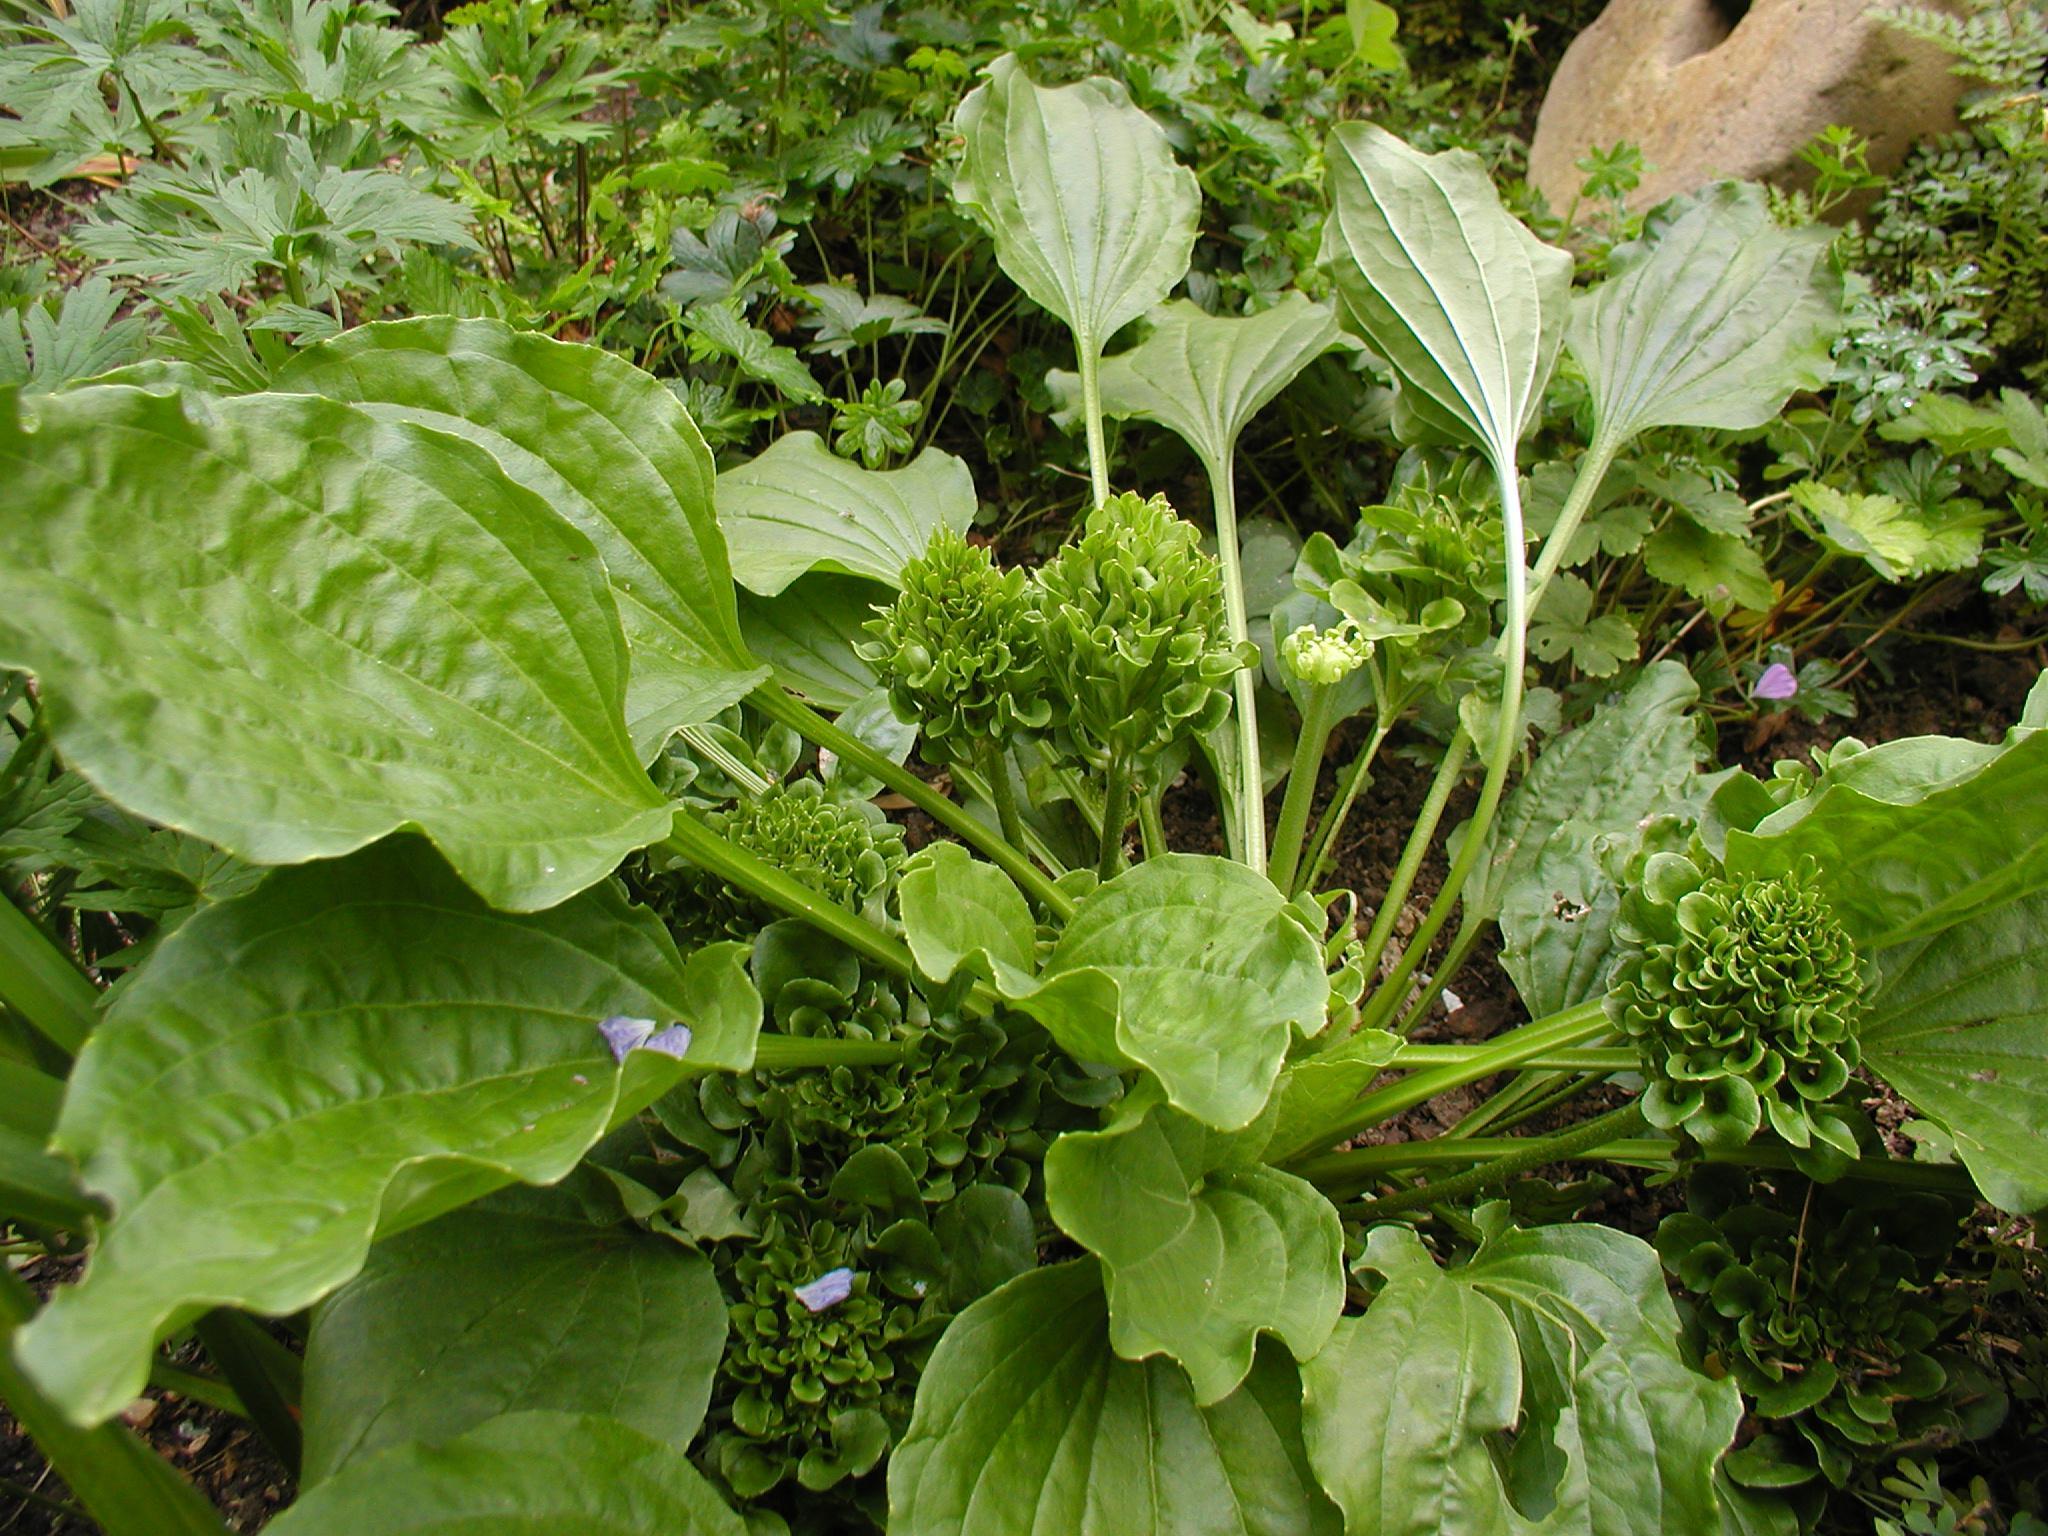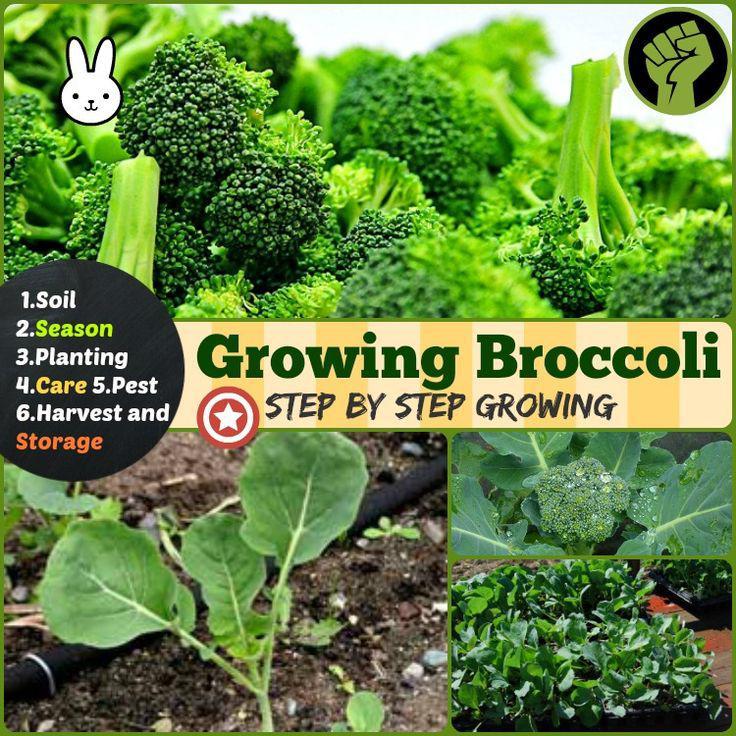The first image is the image on the left, the second image is the image on the right. Analyze the images presented: Is the assertion "There is a single bunch of brocolli in the image on the left." valid? Answer yes or no. No. 